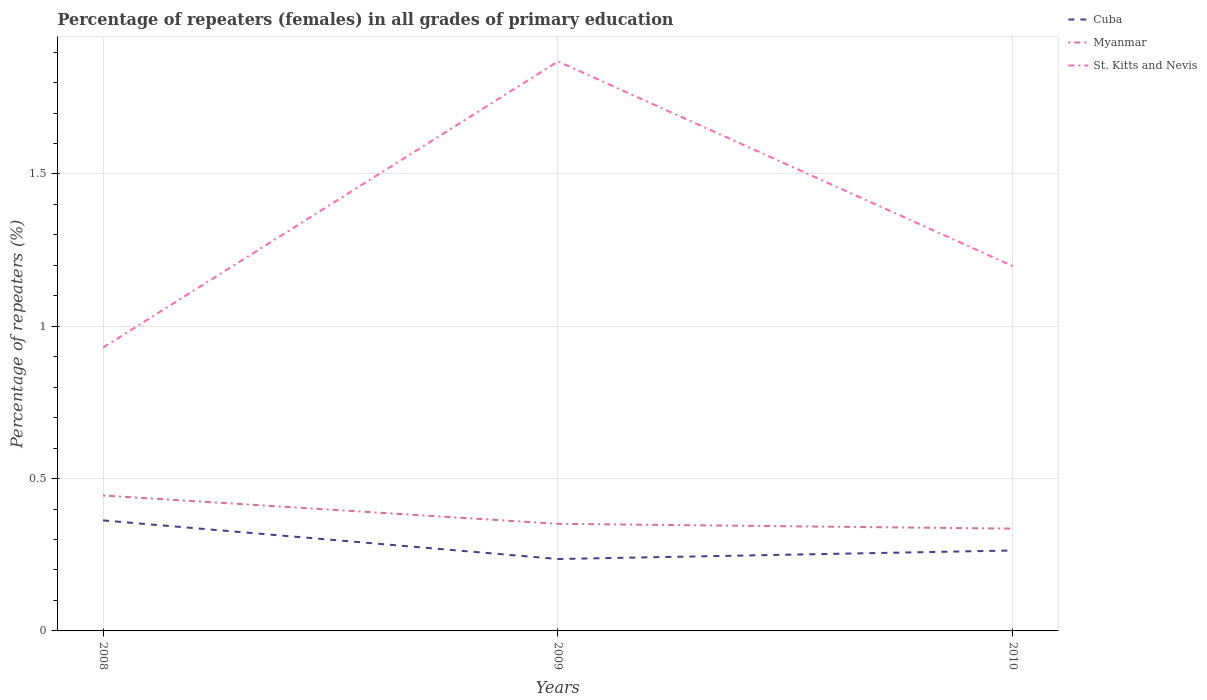Across all years, what is the maximum percentage of repeaters (females) in St. Kitts and Nevis?
Offer a very short reply. 0.93. In which year was the percentage of repeaters (females) in Cuba maximum?
Give a very brief answer. 2009. What is the total percentage of repeaters (females) in Cuba in the graph?
Provide a short and direct response. 0.1. What is the difference between the highest and the second highest percentage of repeaters (females) in St. Kitts and Nevis?
Provide a short and direct response. 0.94. How many years are there in the graph?
Make the answer very short. 3. Does the graph contain grids?
Your response must be concise. Yes. Where does the legend appear in the graph?
Your response must be concise. Top right. How many legend labels are there?
Give a very brief answer. 3. What is the title of the graph?
Make the answer very short. Percentage of repeaters (females) in all grades of primary education. What is the label or title of the X-axis?
Your answer should be compact. Years. What is the label or title of the Y-axis?
Offer a terse response. Percentage of repeaters (%). What is the Percentage of repeaters (%) of Cuba in 2008?
Your response must be concise. 0.36. What is the Percentage of repeaters (%) in Myanmar in 2008?
Provide a succinct answer. 0.44. What is the Percentage of repeaters (%) in St. Kitts and Nevis in 2008?
Provide a short and direct response. 0.93. What is the Percentage of repeaters (%) in Cuba in 2009?
Your answer should be compact. 0.24. What is the Percentage of repeaters (%) in Myanmar in 2009?
Ensure brevity in your answer.  0.35. What is the Percentage of repeaters (%) in St. Kitts and Nevis in 2009?
Offer a terse response. 1.87. What is the Percentage of repeaters (%) of Cuba in 2010?
Your answer should be compact. 0.26. What is the Percentage of repeaters (%) of Myanmar in 2010?
Provide a short and direct response. 0.34. What is the Percentage of repeaters (%) of St. Kitts and Nevis in 2010?
Ensure brevity in your answer.  1.2. Across all years, what is the maximum Percentage of repeaters (%) in Cuba?
Ensure brevity in your answer.  0.36. Across all years, what is the maximum Percentage of repeaters (%) of Myanmar?
Give a very brief answer. 0.44. Across all years, what is the maximum Percentage of repeaters (%) in St. Kitts and Nevis?
Offer a terse response. 1.87. Across all years, what is the minimum Percentage of repeaters (%) in Cuba?
Offer a terse response. 0.24. Across all years, what is the minimum Percentage of repeaters (%) in Myanmar?
Ensure brevity in your answer.  0.34. Across all years, what is the minimum Percentage of repeaters (%) of St. Kitts and Nevis?
Keep it short and to the point. 0.93. What is the total Percentage of repeaters (%) in Cuba in the graph?
Provide a short and direct response. 0.86. What is the total Percentage of repeaters (%) in Myanmar in the graph?
Give a very brief answer. 1.13. What is the total Percentage of repeaters (%) in St. Kitts and Nevis in the graph?
Ensure brevity in your answer.  4. What is the difference between the Percentage of repeaters (%) of Cuba in 2008 and that in 2009?
Offer a terse response. 0.13. What is the difference between the Percentage of repeaters (%) of Myanmar in 2008 and that in 2009?
Provide a short and direct response. 0.09. What is the difference between the Percentage of repeaters (%) of St. Kitts and Nevis in 2008 and that in 2009?
Offer a very short reply. -0.94. What is the difference between the Percentage of repeaters (%) in Cuba in 2008 and that in 2010?
Make the answer very short. 0.1. What is the difference between the Percentage of repeaters (%) of Myanmar in 2008 and that in 2010?
Ensure brevity in your answer.  0.11. What is the difference between the Percentage of repeaters (%) in St. Kitts and Nevis in 2008 and that in 2010?
Provide a succinct answer. -0.27. What is the difference between the Percentage of repeaters (%) in Cuba in 2009 and that in 2010?
Your answer should be very brief. -0.03. What is the difference between the Percentage of repeaters (%) in Myanmar in 2009 and that in 2010?
Your response must be concise. 0.02. What is the difference between the Percentage of repeaters (%) of St. Kitts and Nevis in 2009 and that in 2010?
Ensure brevity in your answer.  0.67. What is the difference between the Percentage of repeaters (%) in Cuba in 2008 and the Percentage of repeaters (%) in Myanmar in 2009?
Ensure brevity in your answer.  0.01. What is the difference between the Percentage of repeaters (%) of Cuba in 2008 and the Percentage of repeaters (%) of St. Kitts and Nevis in 2009?
Make the answer very short. -1.51. What is the difference between the Percentage of repeaters (%) in Myanmar in 2008 and the Percentage of repeaters (%) in St. Kitts and Nevis in 2009?
Keep it short and to the point. -1.42. What is the difference between the Percentage of repeaters (%) in Cuba in 2008 and the Percentage of repeaters (%) in Myanmar in 2010?
Your answer should be very brief. 0.03. What is the difference between the Percentage of repeaters (%) of Cuba in 2008 and the Percentage of repeaters (%) of St. Kitts and Nevis in 2010?
Ensure brevity in your answer.  -0.83. What is the difference between the Percentage of repeaters (%) in Myanmar in 2008 and the Percentage of repeaters (%) in St. Kitts and Nevis in 2010?
Provide a succinct answer. -0.75. What is the difference between the Percentage of repeaters (%) of Cuba in 2009 and the Percentage of repeaters (%) of Myanmar in 2010?
Provide a succinct answer. -0.1. What is the difference between the Percentage of repeaters (%) of Cuba in 2009 and the Percentage of repeaters (%) of St. Kitts and Nevis in 2010?
Make the answer very short. -0.96. What is the difference between the Percentage of repeaters (%) in Myanmar in 2009 and the Percentage of repeaters (%) in St. Kitts and Nevis in 2010?
Ensure brevity in your answer.  -0.85. What is the average Percentage of repeaters (%) of Cuba per year?
Make the answer very short. 0.29. What is the average Percentage of repeaters (%) in Myanmar per year?
Your answer should be very brief. 0.38. What is the average Percentage of repeaters (%) of St. Kitts and Nevis per year?
Provide a short and direct response. 1.33. In the year 2008, what is the difference between the Percentage of repeaters (%) of Cuba and Percentage of repeaters (%) of Myanmar?
Give a very brief answer. -0.08. In the year 2008, what is the difference between the Percentage of repeaters (%) in Cuba and Percentage of repeaters (%) in St. Kitts and Nevis?
Make the answer very short. -0.57. In the year 2008, what is the difference between the Percentage of repeaters (%) in Myanmar and Percentage of repeaters (%) in St. Kitts and Nevis?
Provide a short and direct response. -0.49. In the year 2009, what is the difference between the Percentage of repeaters (%) of Cuba and Percentage of repeaters (%) of Myanmar?
Your response must be concise. -0.12. In the year 2009, what is the difference between the Percentage of repeaters (%) of Cuba and Percentage of repeaters (%) of St. Kitts and Nevis?
Your answer should be compact. -1.63. In the year 2009, what is the difference between the Percentage of repeaters (%) of Myanmar and Percentage of repeaters (%) of St. Kitts and Nevis?
Provide a succinct answer. -1.52. In the year 2010, what is the difference between the Percentage of repeaters (%) in Cuba and Percentage of repeaters (%) in Myanmar?
Your response must be concise. -0.07. In the year 2010, what is the difference between the Percentage of repeaters (%) of Cuba and Percentage of repeaters (%) of St. Kitts and Nevis?
Provide a short and direct response. -0.93. In the year 2010, what is the difference between the Percentage of repeaters (%) of Myanmar and Percentage of repeaters (%) of St. Kitts and Nevis?
Keep it short and to the point. -0.86. What is the ratio of the Percentage of repeaters (%) of Cuba in 2008 to that in 2009?
Ensure brevity in your answer.  1.54. What is the ratio of the Percentage of repeaters (%) of Myanmar in 2008 to that in 2009?
Provide a succinct answer. 1.26. What is the ratio of the Percentage of repeaters (%) of St. Kitts and Nevis in 2008 to that in 2009?
Offer a very short reply. 0.5. What is the ratio of the Percentage of repeaters (%) of Cuba in 2008 to that in 2010?
Your answer should be very brief. 1.37. What is the ratio of the Percentage of repeaters (%) in Myanmar in 2008 to that in 2010?
Your answer should be compact. 1.32. What is the ratio of the Percentage of repeaters (%) of St. Kitts and Nevis in 2008 to that in 2010?
Offer a terse response. 0.78. What is the ratio of the Percentage of repeaters (%) of Cuba in 2009 to that in 2010?
Your response must be concise. 0.89. What is the ratio of the Percentage of repeaters (%) of Myanmar in 2009 to that in 2010?
Make the answer very short. 1.05. What is the ratio of the Percentage of repeaters (%) in St. Kitts and Nevis in 2009 to that in 2010?
Your answer should be very brief. 1.56. What is the difference between the highest and the second highest Percentage of repeaters (%) in Cuba?
Your answer should be very brief. 0.1. What is the difference between the highest and the second highest Percentage of repeaters (%) in Myanmar?
Offer a very short reply. 0.09. What is the difference between the highest and the second highest Percentage of repeaters (%) in St. Kitts and Nevis?
Ensure brevity in your answer.  0.67. What is the difference between the highest and the lowest Percentage of repeaters (%) of Cuba?
Keep it short and to the point. 0.13. What is the difference between the highest and the lowest Percentage of repeaters (%) in Myanmar?
Make the answer very short. 0.11. What is the difference between the highest and the lowest Percentage of repeaters (%) of St. Kitts and Nevis?
Offer a terse response. 0.94. 